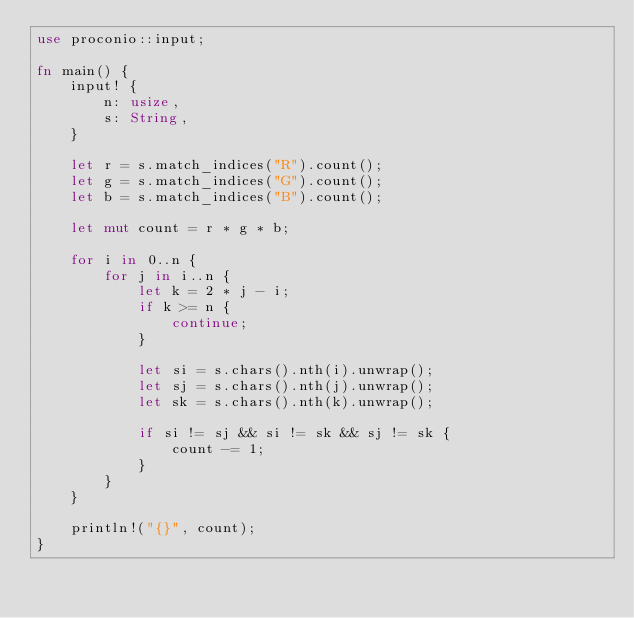Convert code to text. <code><loc_0><loc_0><loc_500><loc_500><_Rust_>use proconio::input;

fn main() {
    input! {
        n: usize,
        s: String,
    }

    let r = s.match_indices("R").count();
    let g = s.match_indices("G").count();
    let b = s.match_indices("B").count();

    let mut count = r * g * b;

    for i in 0..n {
        for j in i..n {
            let k = 2 * j - i;
            if k >= n {
                continue;
            }

            let si = s.chars().nth(i).unwrap();
            let sj = s.chars().nth(j).unwrap();
            let sk = s.chars().nth(k).unwrap();

            if si != sj && si != sk && sj != sk {
                count -= 1;
            }
        }
    }

    println!("{}", count);
}
</code> 